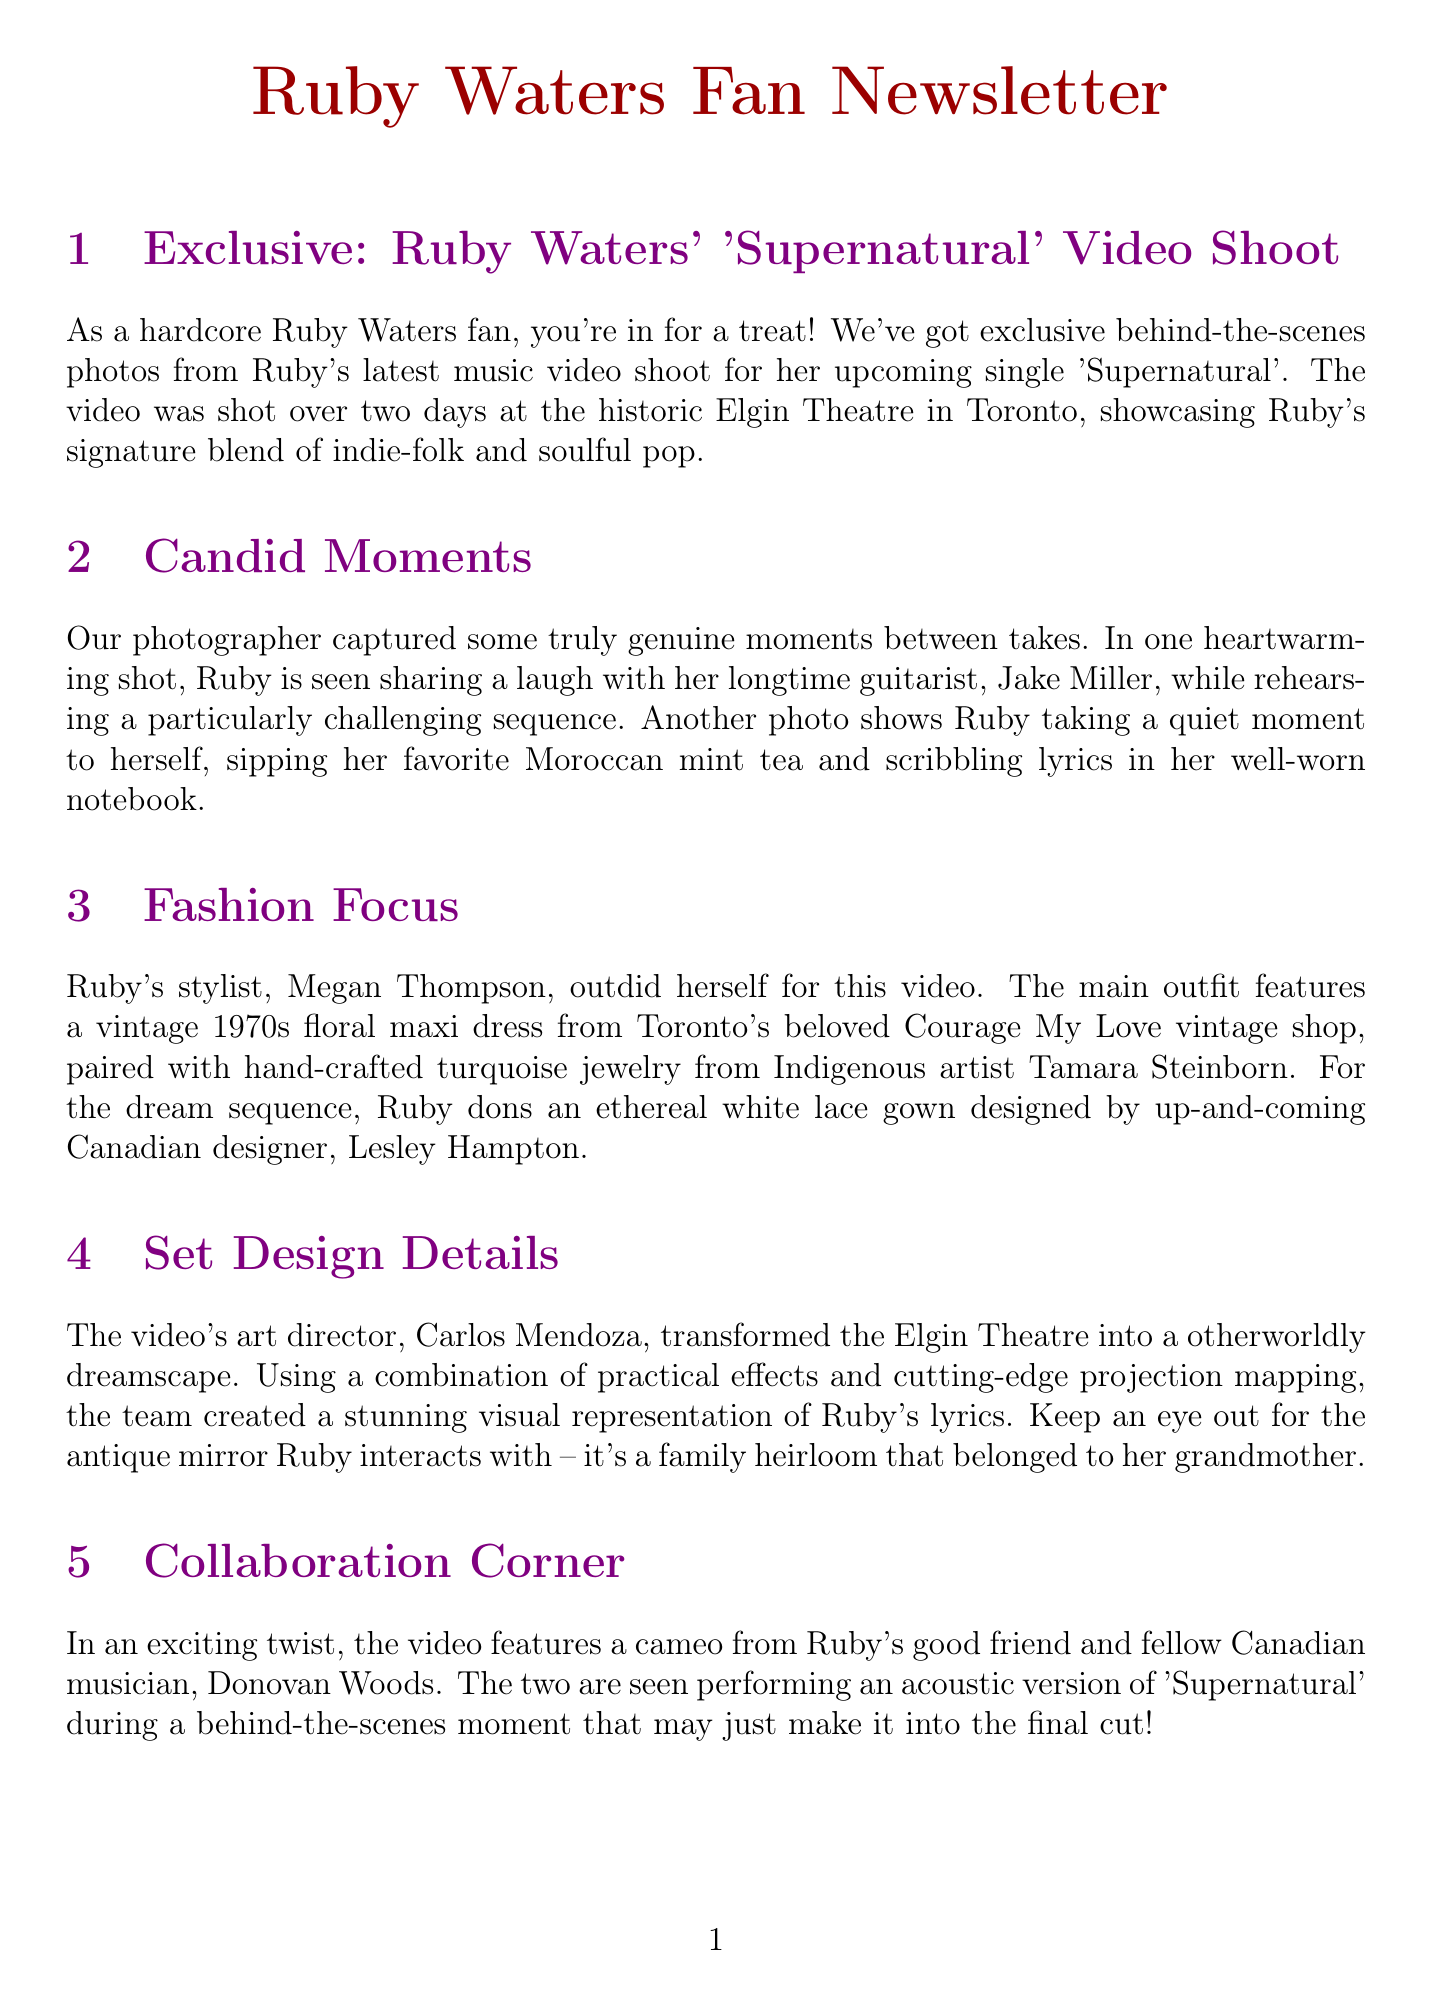What is the title of Ruby Waters' upcoming single? The title of Ruby Waters' upcoming single is mentioned in the first section of the newsletter.
Answer: Supernatural Who is Ruby's longtime guitarist? The newsletter provides the name of Ruby's longtime guitarist in the Candid Moments section.
Answer: Jake Miller What type of dress does Ruby wear in the main outfit? The document details Ruby's outfit in the Fashion Focus section, specifying the type of dress.
Answer: Floral maxi dress Who designed the ethereal white lace gown? The specific designer of the white lace gown is mentioned in the Fashion Focus section of the newsletter.
Answer: Lesley Hampton How many contest winners were invited to be extras? The newsletter states the exact number of contest winners included in the Fan Engagement section.
Answer: Five What was transformed into a dreamscape for the video? The Set Design Details section describes the location transformed for the shoot.
Answer: Elgin Theatre What beverage was Ruby seen sipping? A detail about Ruby's candid moment is mentioned in the Candid Moments section.
Answer: Moroccan mint tea Which musician made a cameo in the video? The newsletter lists the name of the musician who made a cameo in the Collaboration Corner section.
Answer: Donovan Woods 